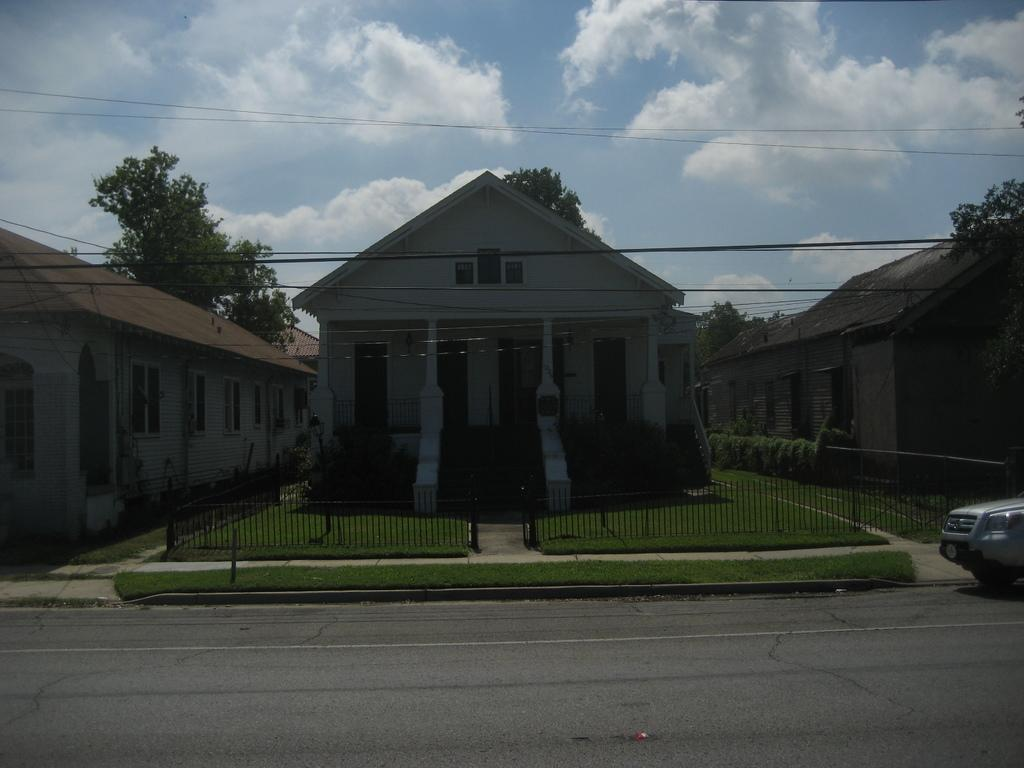What is the condition of the sky in the image? The sky is cloudy in the image. What type of structures can be seen in the image? There are buildings in the image. What type of vegetation is present in the image? Grass is present in the image. What type of barrier can be seen in the image? There is a fence in the image. What mode of transportation is visible in the image? A vehicle is visible in the image. What type of natural feature is present in the image? Trees are present in the image. What type of plastic is covering the trees in the image? There is no plastic covering the trees in the image; the trees are not covered. 